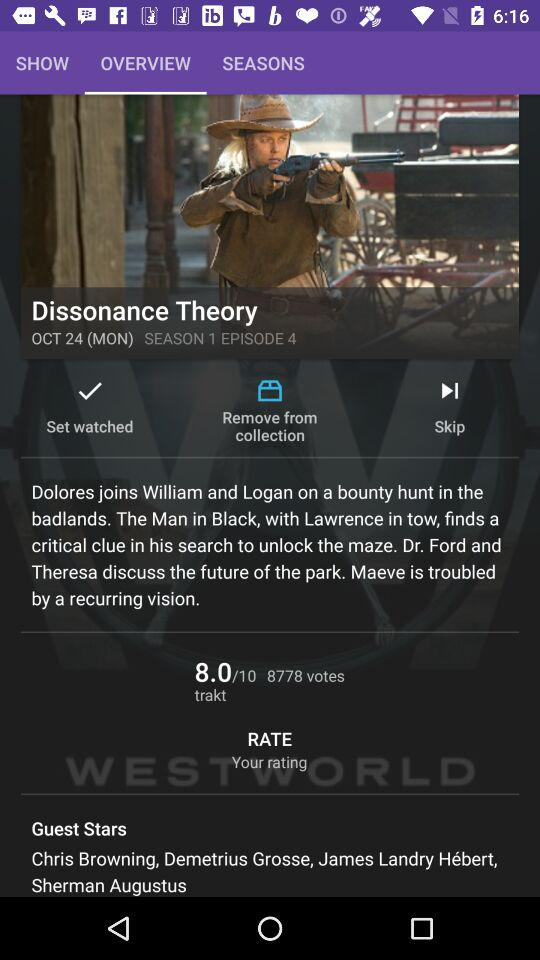How many votes are there? There are 8778 votes. 